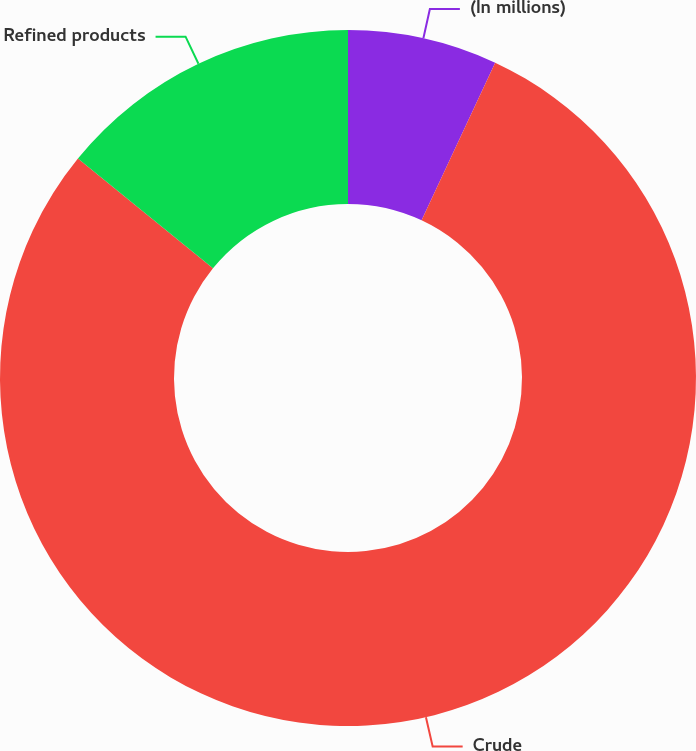<chart> <loc_0><loc_0><loc_500><loc_500><pie_chart><fcel>(In millions)<fcel>Crude<fcel>Refined products<nl><fcel>6.95%<fcel>78.91%<fcel>14.14%<nl></chart> 